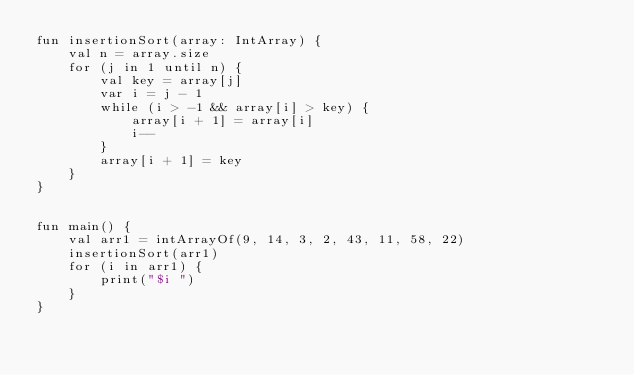<code> <loc_0><loc_0><loc_500><loc_500><_Kotlin_>fun insertionSort(array: IntArray) {
    val n = array.size
    for (j in 1 until n) {
        val key = array[j]
        var i = j - 1
        while (i > -1 && array[i] > key) {
            array[i + 1] = array[i]
            i--
        }
        array[i + 1] = key
    }
}


fun main() {
    val arr1 = intArrayOf(9, 14, 3, 2, 43, 11, 58, 22)
    insertionSort(arr1)
    for (i in arr1) {
        print("$i ")
    }
}
</code> 